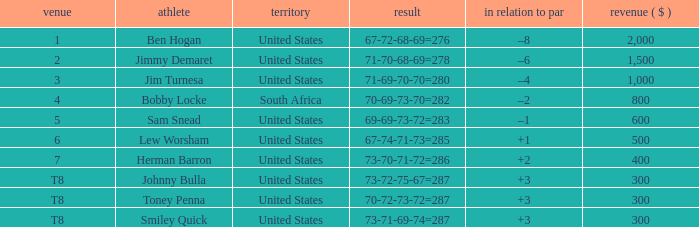What is the Money of the Player in Place 5? 600.0. 